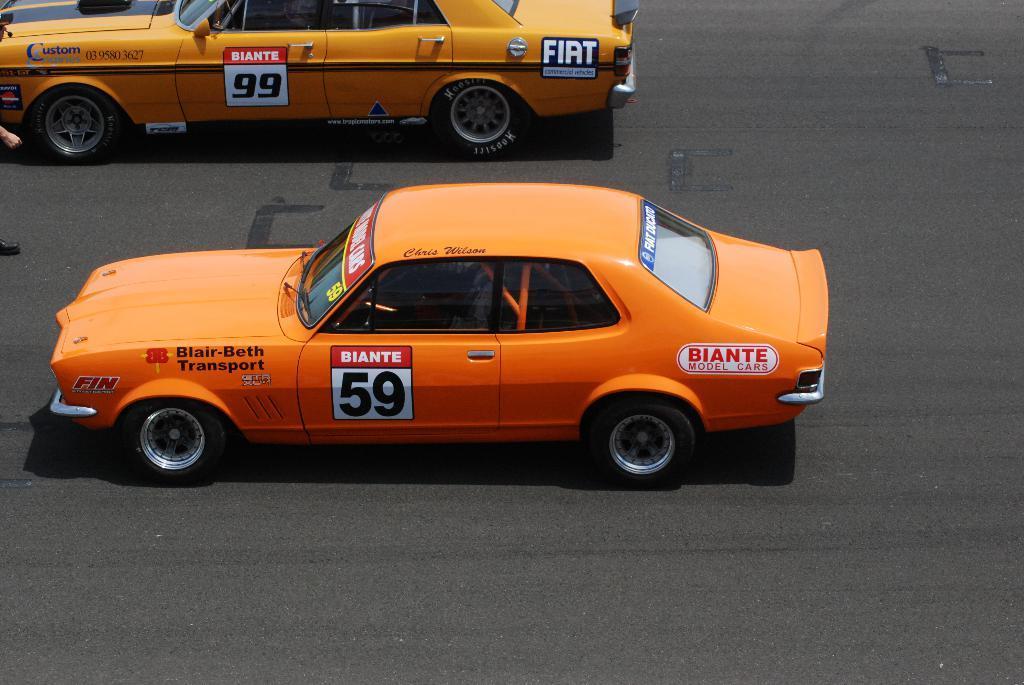How would you summarize this image in a sentence or two? In this image there are two cars on the road. Left side a person is standing on the road. 